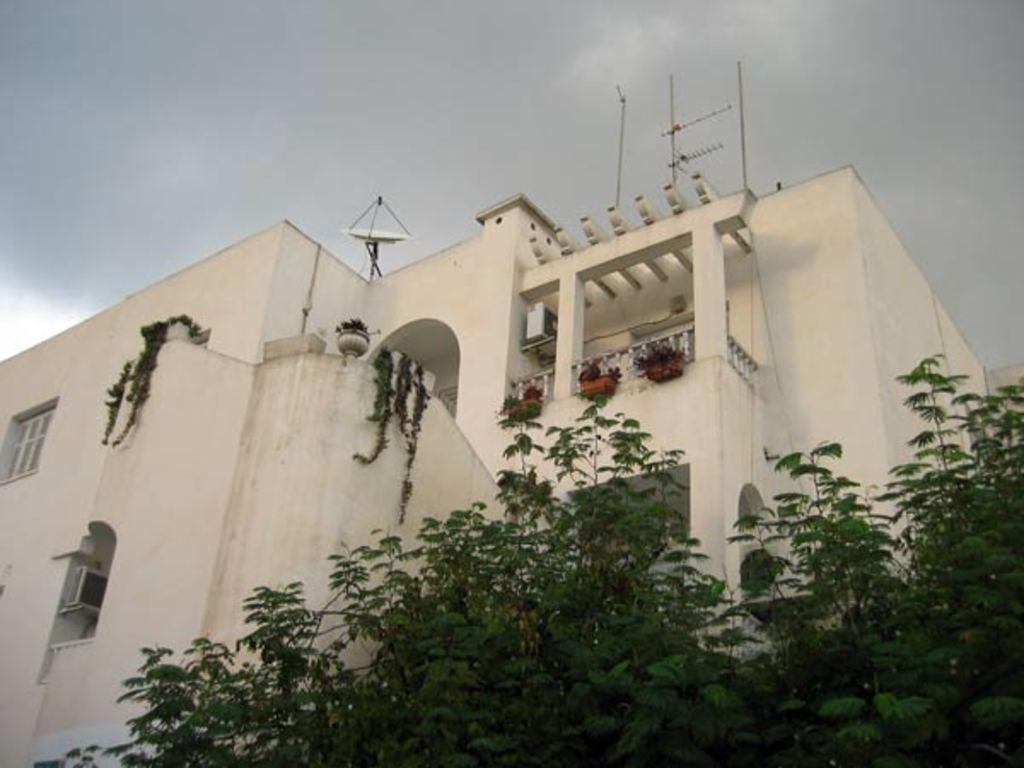What type of building is in the image? There is a white building in the image. Are there any decorative elements on the building? Yes, the building has decorative flower pots. What can be seen in the front bottom side of the image? There is a tree in the front bottom side of the image. What type of furniture is visible in the image? There is no furniture visible in the image; it only features a white building, decorative flower pots, and a tree. 